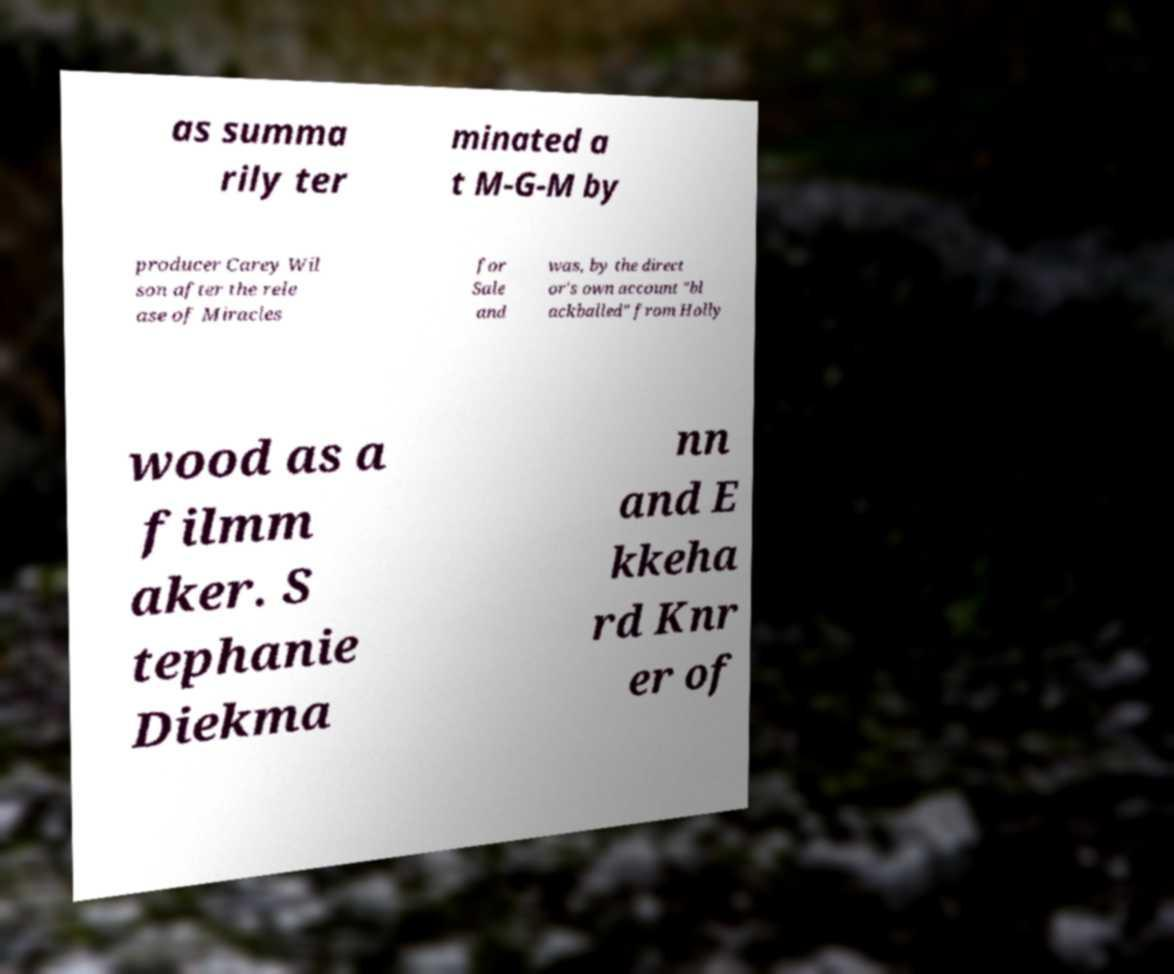I need the written content from this picture converted into text. Can you do that? as summa rily ter minated a t M-G-M by producer Carey Wil son after the rele ase of Miracles for Sale and was, by the direct or's own account "bl ackballed" from Holly wood as a filmm aker. S tephanie Diekma nn and E kkeha rd Knr er of 